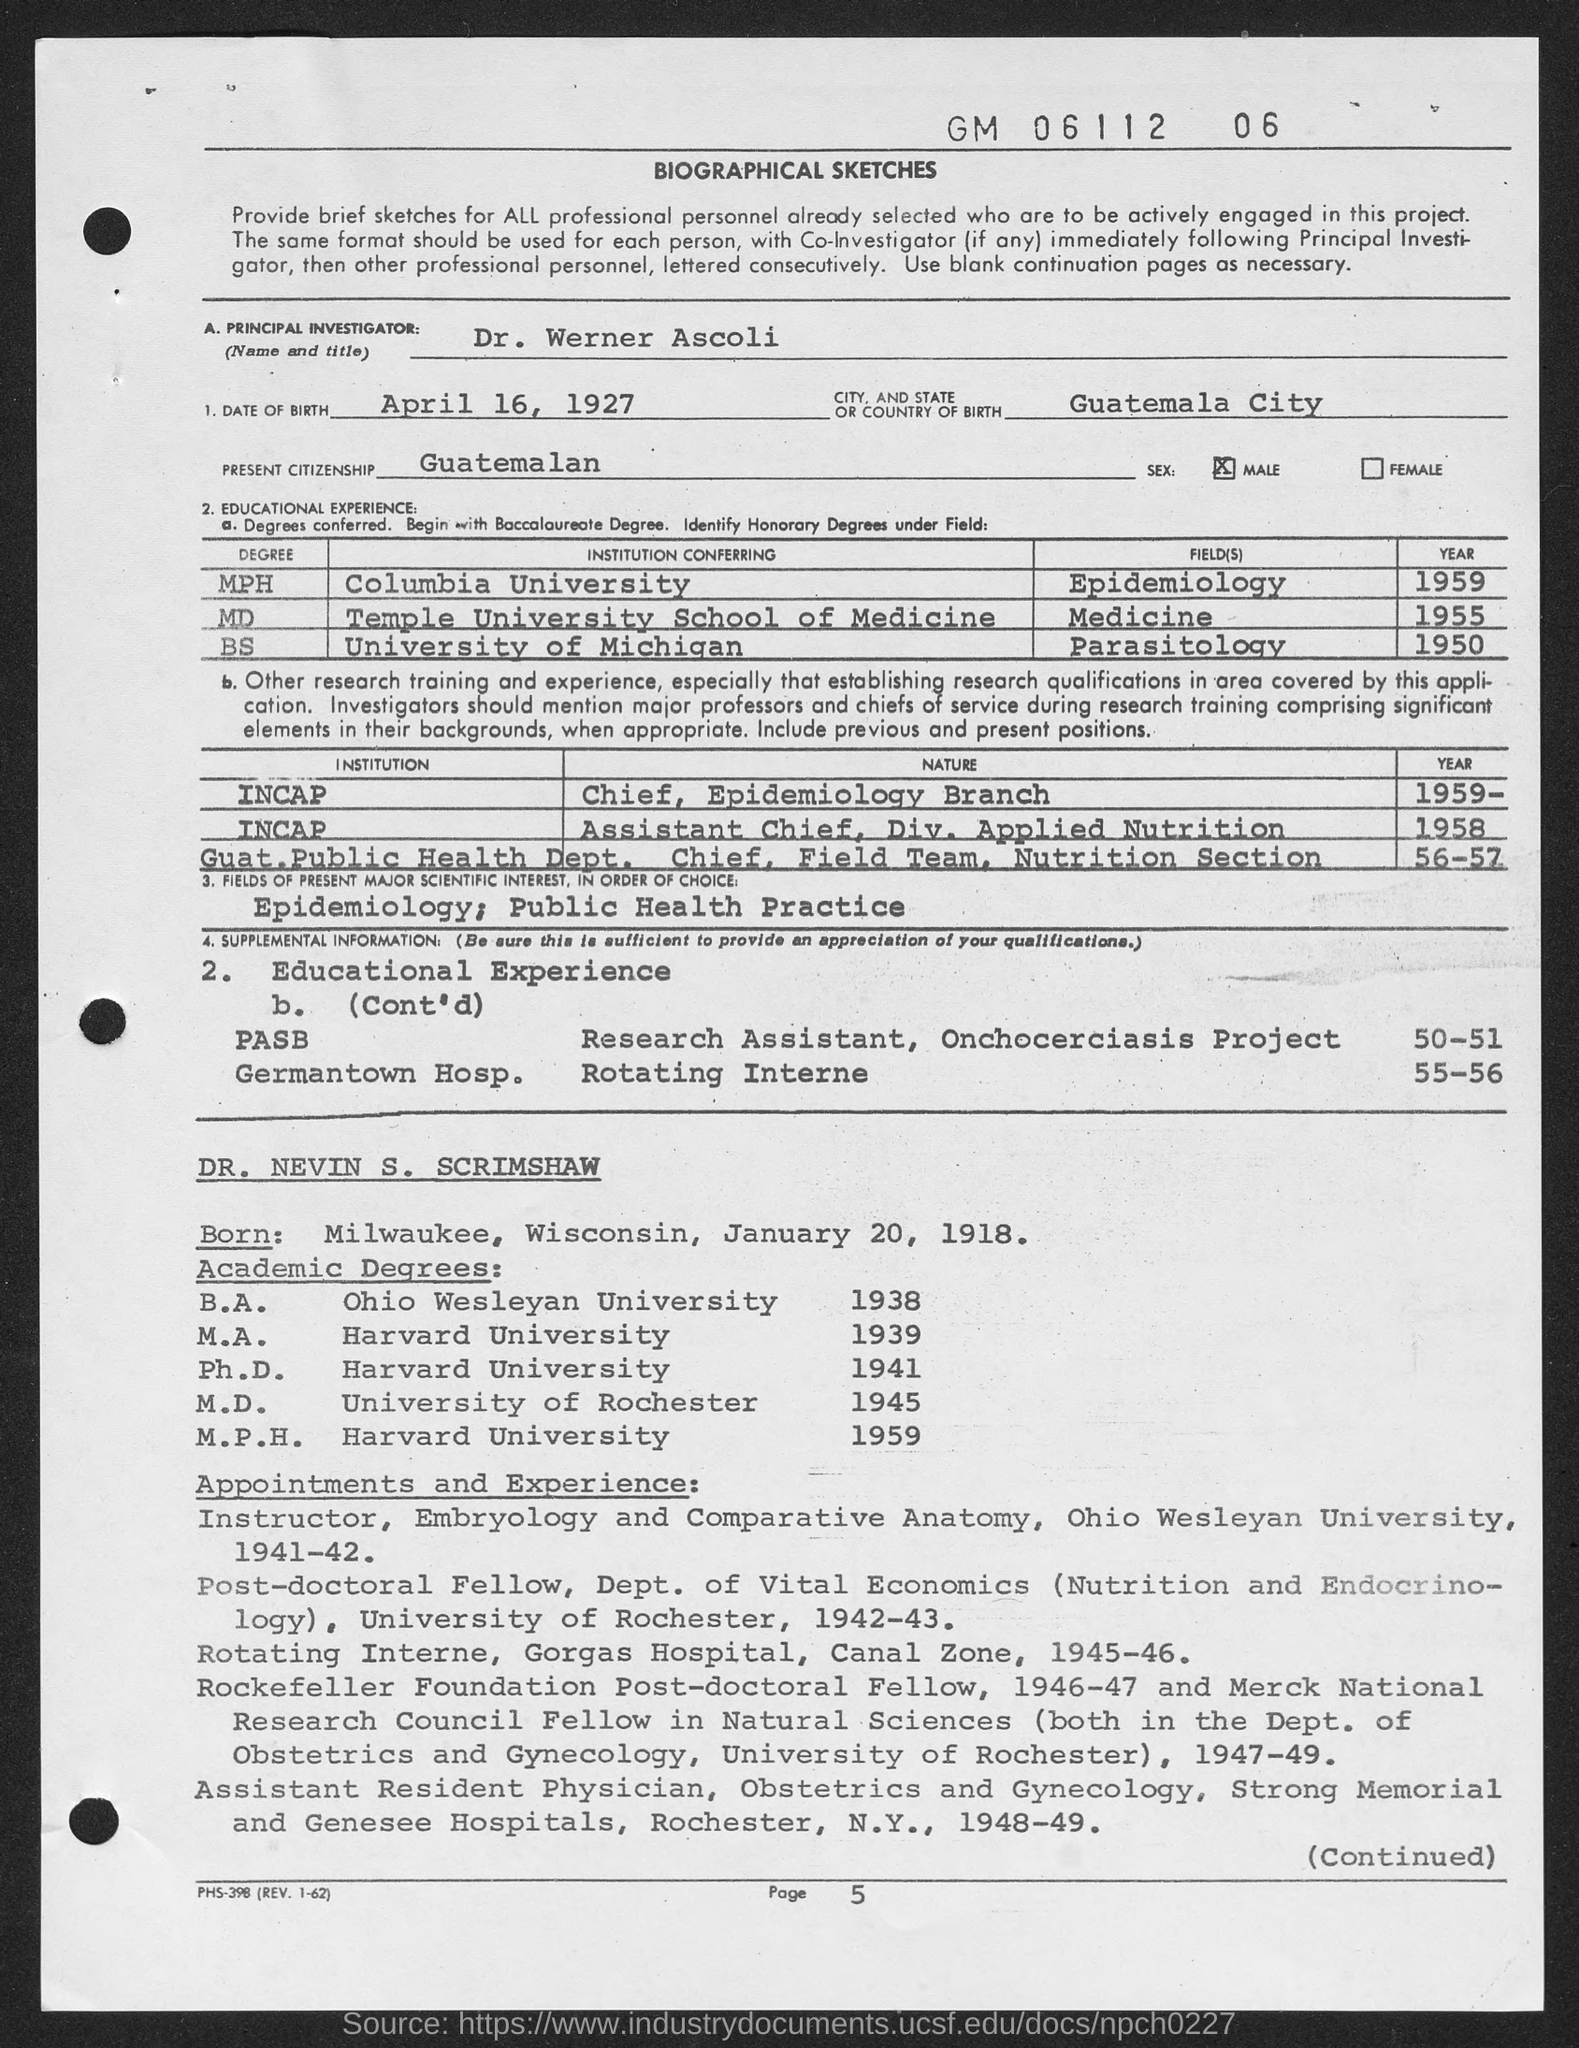What is the name of the principal investigator given in the document?
Your response must be concise. Dr. Werner Ascoli. What is the date of birth of Dr. Werner Ascoli?
Provide a short and direct response. April 16, 1927. Which is the place of birth of Dr. Werner Ascoli?
Make the answer very short. Guatemala City. When did Dr. Werner Ascoli completed his MPH degree in Epidemiology?
Provide a short and direct response. 1959. In which university, Dr. Werner Ascoli completed his BS degree in Parasitology?
Give a very brief answer. University of Michigan. What is the present citizenship of Dr. Werner Ascoli?
Your answer should be very brief. Guatemalan. What is the date of birth of DR. NEVIN S. SCRIMSHAW?
Provide a succinct answer. January 20, 1918. When did DR. NEVIN S. SCRIMSHAW completed M.D. degree from University of Rochester?
Ensure brevity in your answer.  1945. In which university, DR. NEVIN S. SCRIMSHAW completed his M.P.H. degree?
Make the answer very short. Harvard University. 